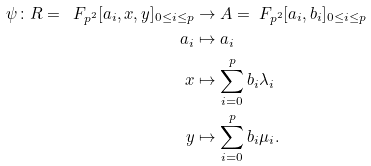<formula> <loc_0><loc_0><loc_500><loc_500>\psi \colon R = \ F _ { p ^ { 2 } } [ a _ { i } , x , y ] _ { 0 \leq i \leq p } & \rightarrow A = \ F _ { p ^ { 2 } } [ a _ { i } , b _ { i } ] _ { 0 \leq i \leq p } \\ a _ { i } & \mapsto a _ { i } \\ x & \mapsto \sum _ { i = 0 } ^ { p } b _ { i } \lambda _ { i } \\ y & \mapsto \sum _ { i = 0 } ^ { p } b _ { i } \mu _ { i } .</formula> 